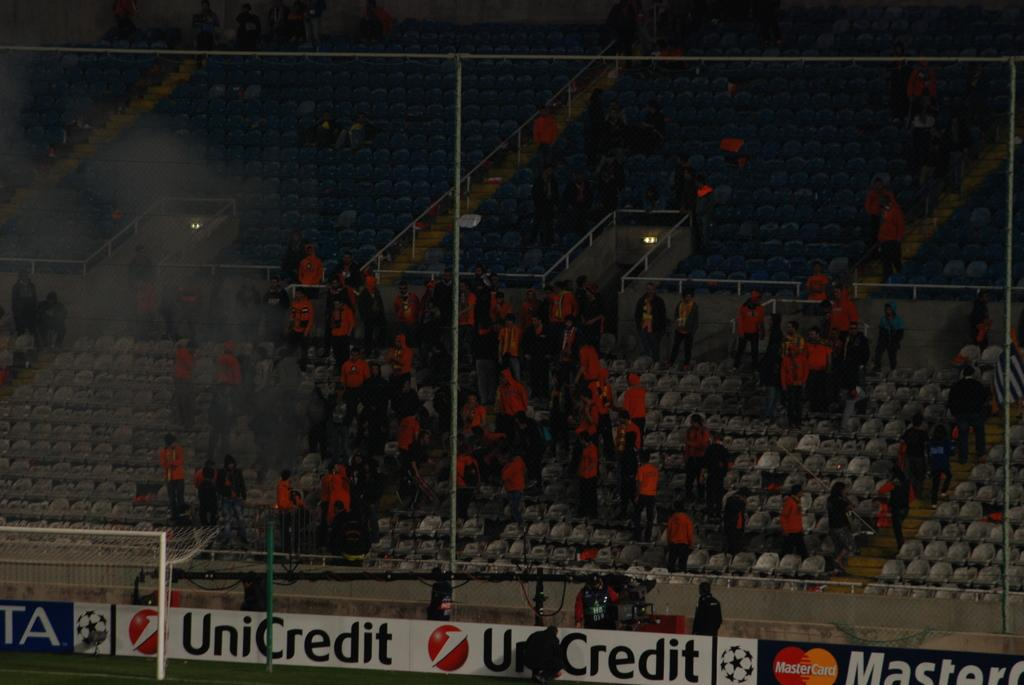<image>
Summarize the visual content of the image. A sports stadium has ads for MasterCard and UniCredit on its spectator stands. 